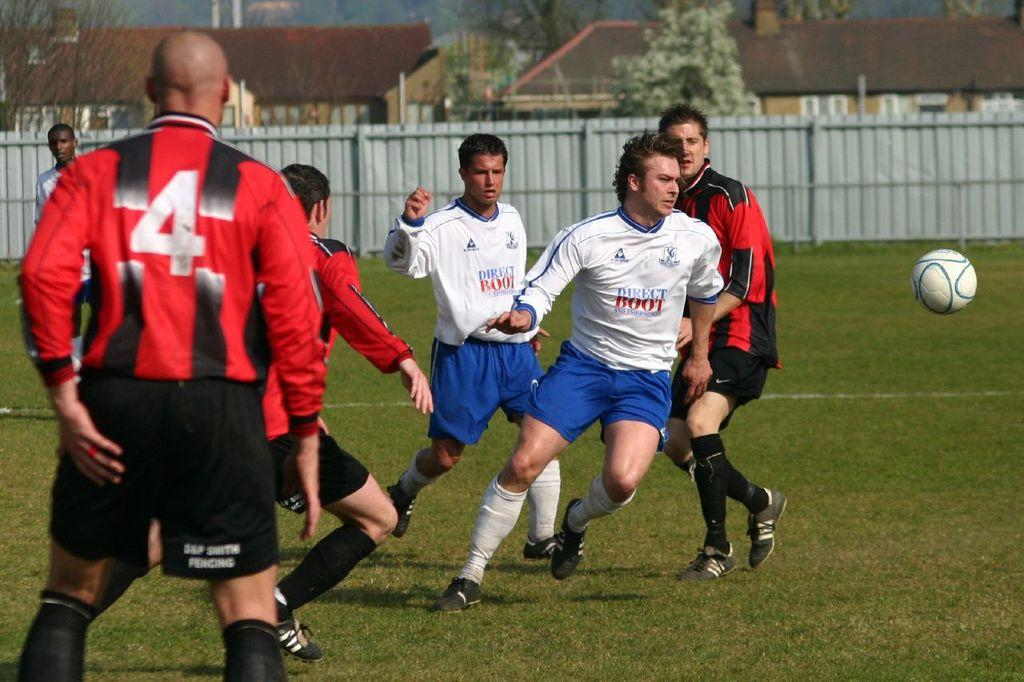Provide a one-sentence caption for the provided image. soccer players with white Direct Boot jerseys and red and black striped jerseys playing a game. 